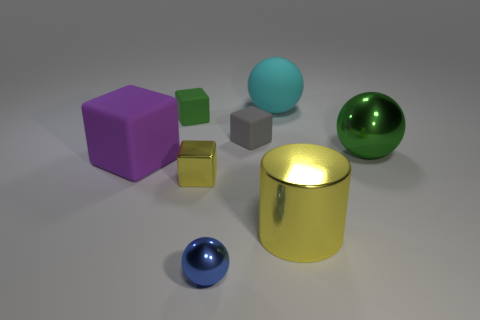Does the metal object on the left side of the blue metal ball have the same size as the big rubber block?
Provide a succinct answer. No. How many objects are tiny green blocks or big green metallic objects?
Keep it short and to the point. 2. The green thing that is on the right side of the large rubber thing behind the big thing right of the large cylinder is made of what material?
Ensure brevity in your answer.  Metal. What material is the ball right of the big rubber sphere?
Offer a very short reply. Metal. Are there any brown cylinders of the same size as the yellow cylinder?
Your response must be concise. No. Is the color of the metal object to the right of the large yellow shiny object the same as the metallic block?
Ensure brevity in your answer.  No. What number of green objects are either big rubber blocks or metal spheres?
Your answer should be very brief. 1. How many small metal cubes are the same color as the cylinder?
Give a very brief answer. 1. Are the blue ball and the large green thing made of the same material?
Your answer should be very brief. Yes. What number of big green objects are left of the big object on the left side of the blue shiny object?
Keep it short and to the point. 0. 